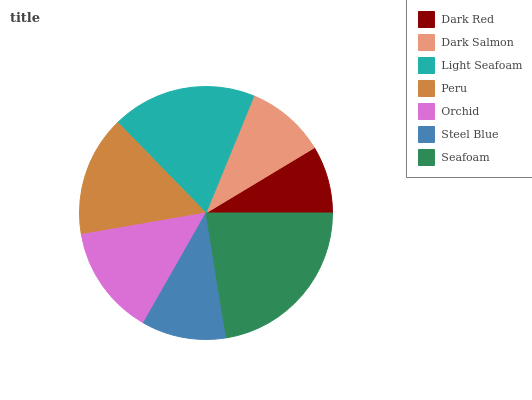Is Dark Red the minimum?
Answer yes or no. Yes. Is Seafoam the maximum?
Answer yes or no. Yes. Is Dark Salmon the minimum?
Answer yes or no. No. Is Dark Salmon the maximum?
Answer yes or no. No. Is Dark Salmon greater than Dark Red?
Answer yes or no. Yes. Is Dark Red less than Dark Salmon?
Answer yes or no. Yes. Is Dark Red greater than Dark Salmon?
Answer yes or no. No. Is Dark Salmon less than Dark Red?
Answer yes or no. No. Is Orchid the high median?
Answer yes or no. Yes. Is Orchid the low median?
Answer yes or no. Yes. Is Seafoam the high median?
Answer yes or no. No. Is Peru the low median?
Answer yes or no. No. 